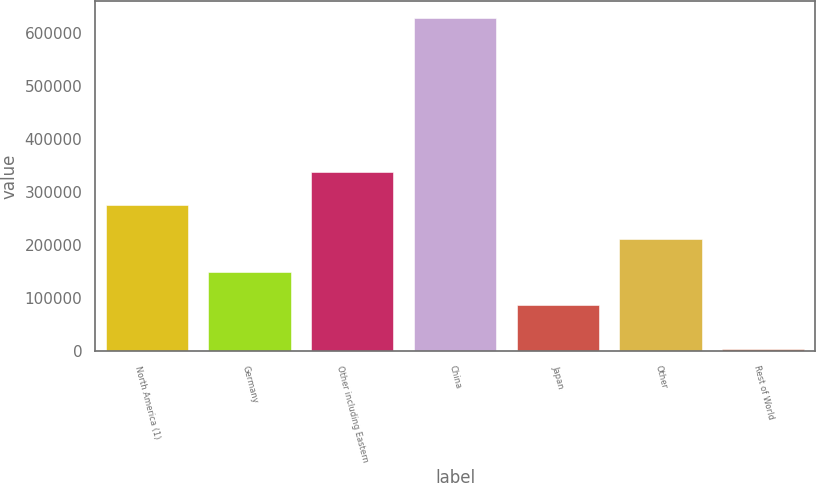Convert chart. <chart><loc_0><loc_0><loc_500><loc_500><bar_chart><fcel>North America (1)<fcel>Germany<fcel>Other including Eastern<fcel>China<fcel>Japan<fcel>Other<fcel>Rest of World<nl><fcel>274841<fcel>150026<fcel>337248<fcel>629079<fcel>87619<fcel>212434<fcel>5006<nl></chart> 